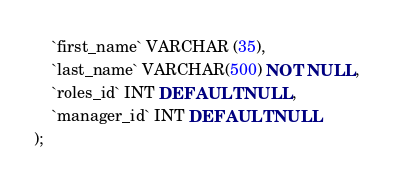<code> <loc_0><loc_0><loc_500><loc_500><_SQL_>	`first_name` VARCHAR (35),
    `last_name` VARCHAR(500) NOT NULL,	
    `roles_id` INT DEFAULT NULL,
    `manager_id` INT DEFAULT NULL
);
</code> 